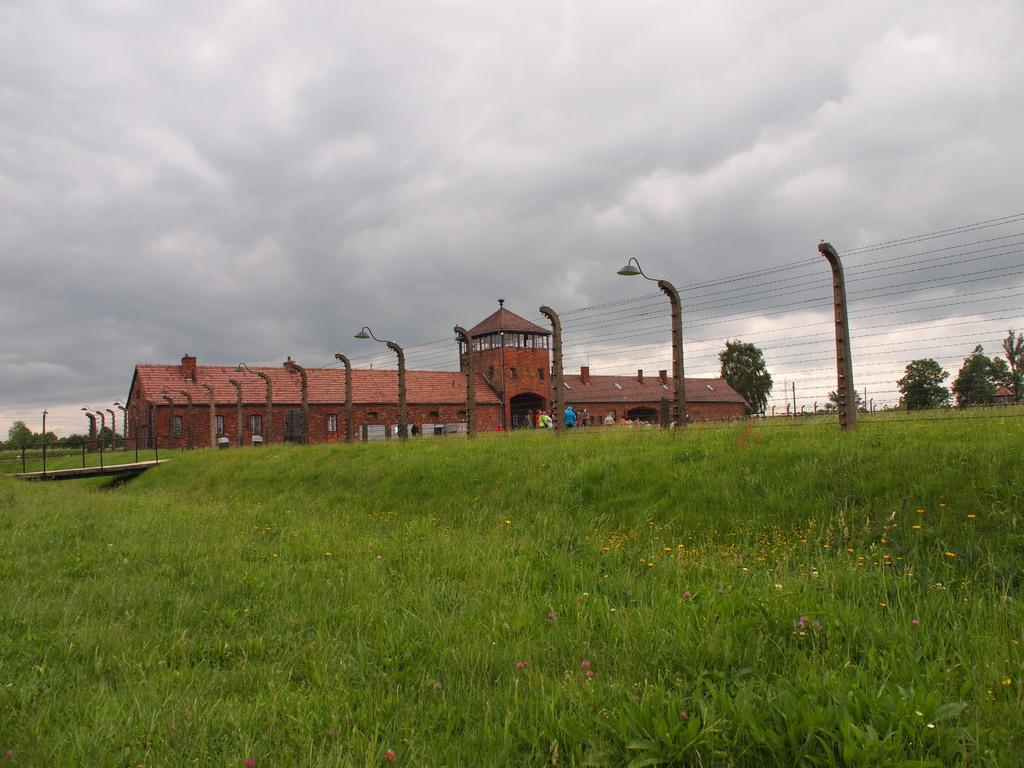Could you give a brief overview of what you see in this image? This image consists of a house in red color. At the bottom, we can see the grass. On the right, there is a fencing along with the trees. At the top, there are clouds in the sky. On the left, we can see a small bridge made up of wood. 